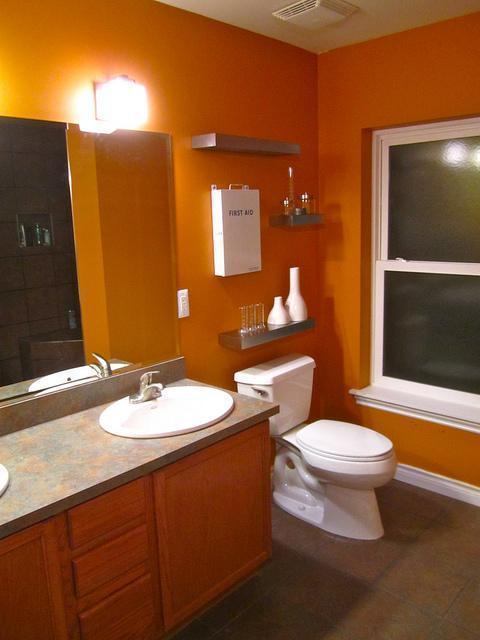What color is the writing on front of the first aid case on the wall?
From the following set of four choices, select the accurate answer to respond to the question.
Options: Yellow, red, black, blue. Black. What is the toilet near?
Indicate the correct choice and explain in the format: 'Answer: answer
Rationale: rationale.'
Options: Baby, kitten, poster, window. Answer: window.
Rationale: The glass panes of a window can be seen right next to the toilet. 